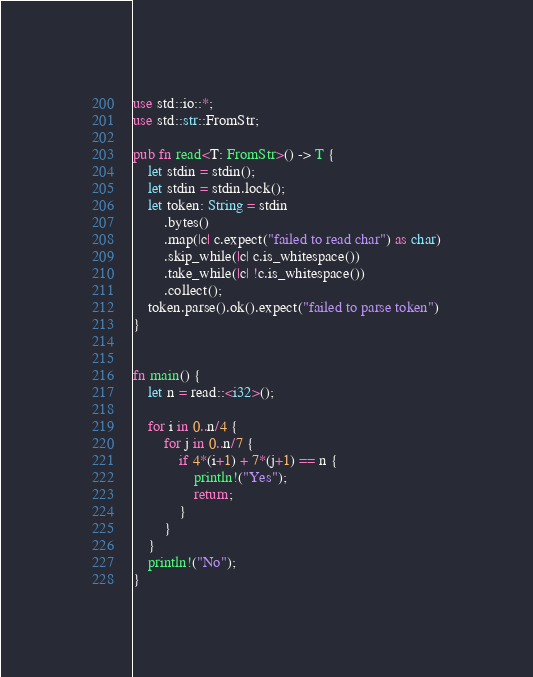<code> <loc_0><loc_0><loc_500><loc_500><_Rust_>use std::io::*;
use std::str::FromStr;

pub fn read<T: FromStr>() -> T {
    let stdin = stdin();
    let stdin = stdin.lock();
    let token: String = stdin
        .bytes()
        .map(|c| c.expect("failed to read char") as char)
        .skip_while(|c| c.is_whitespace())
        .take_while(|c| !c.is_whitespace())
        .collect();
    token.parse().ok().expect("failed to parse token")
}


fn main() {
    let n = read::<i32>();

    for i in 0..n/4 {
        for j in 0..n/7 {
            if 4*(i+1) + 7*(j+1) == n {
                println!("Yes");
                return;
            }
        }
    }
    println!("No");
}</code> 